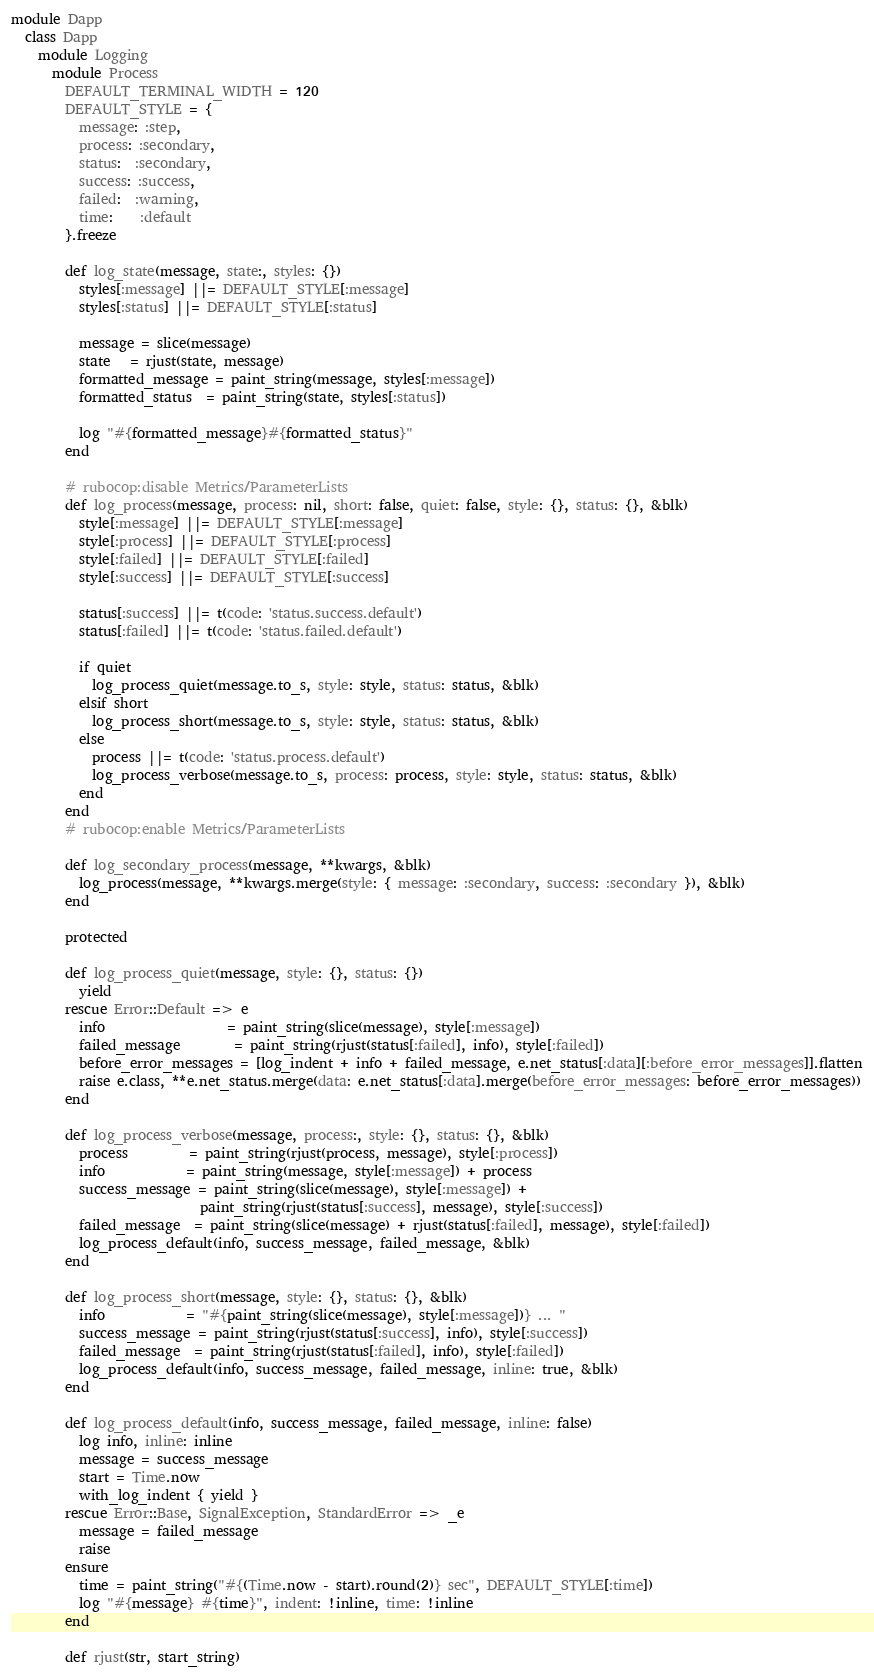Convert code to text. <code><loc_0><loc_0><loc_500><loc_500><_Ruby_>module Dapp
  class Dapp
    module Logging
      module Process
        DEFAULT_TERMINAL_WIDTH = 120
        DEFAULT_STYLE = {
          message: :step,
          process: :secondary,
          status:  :secondary,
          success: :success,
          failed:  :warning,
          time:    :default
        }.freeze

        def log_state(message, state:, styles: {})
          styles[:message] ||= DEFAULT_STYLE[:message]
          styles[:status] ||= DEFAULT_STYLE[:status]

          message = slice(message)
          state   = rjust(state, message)
          formatted_message = paint_string(message, styles[:message])
          formatted_status  = paint_string(state, styles[:status])

          log "#{formatted_message}#{formatted_status}"
        end

        # rubocop:disable Metrics/ParameterLists
        def log_process(message, process: nil, short: false, quiet: false, style: {}, status: {}, &blk)
          style[:message] ||= DEFAULT_STYLE[:message]
          style[:process] ||= DEFAULT_STYLE[:process]
          style[:failed] ||= DEFAULT_STYLE[:failed]
          style[:success] ||= DEFAULT_STYLE[:success]

          status[:success] ||= t(code: 'status.success.default')
          status[:failed] ||= t(code: 'status.failed.default')

          if quiet
            log_process_quiet(message.to_s, style: style, status: status, &blk)
          elsif short
            log_process_short(message.to_s, style: style, status: status, &blk)
          else
            process ||= t(code: 'status.process.default')
            log_process_verbose(message.to_s, process: process, style: style, status: status, &blk)
          end
        end
        # rubocop:enable Metrics/ParameterLists

        def log_secondary_process(message, **kwargs, &blk)
          log_process(message, **kwargs.merge(style: { message: :secondary, success: :secondary }), &blk)
        end

        protected

        def log_process_quiet(message, style: {}, status: {})
          yield
        rescue Error::Default => e
          info                  = paint_string(slice(message), style[:message])
          failed_message        = paint_string(rjust(status[:failed], info), style[:failed])
          before_error_messages = [log_indent + info + failed_message, e.net_status[:data][:before_error_messages]].flatten
          raise e.class, **e.net_status.merge(data: e.net_status[:data].merge(before_error_messages: before_error_messages))
        end

        def log_process_verbose(message, process:, style: {}, status: {}, &blk)
          process         = paint_string(rjust(process, message), style[:process])
          info            = paint_string(message, style[:message]) + process
          success_message = paint_string(slice(message), style[:message]) +
                            paint_string(rjust(status[:success], message), style[:success])
          failed_message  = paint_string(slice(message) + rjust(status[:failed], message), style[:failed])
          log_process_default(info, success_message, failed_message, &blk)
        end

        def log_process_short(message, style: {}, status: {}, &blk)
          info            = "#{paint_string(slice(message), style[:message])} ... "
          success_message = paint_string(rjust(status[:success], info), style[:success])
          failed_message  = paint_string(rjust(status[:failed], info), style[:failed])
          log_process_default(info, success_message, failed_message, inline: true, &blk)
        end

        def log_process_default(info, success_message, failed_message, inline: false)
          log info, inline: inline
          message = success_message
          start = Time.now
          with_log_indent { yield }
        rescue Error::Base, SignalException, StandardError => _e
          message = failed_message
          raise
        ensure
          time = paint_string("#{(Time.now - start).round(2)} sec", DEFAULT_STYLE[:time])
          log "#{message} #{time}", indent: !inline, time: !inline
        end

        def rjust(str, start_string)</code> 